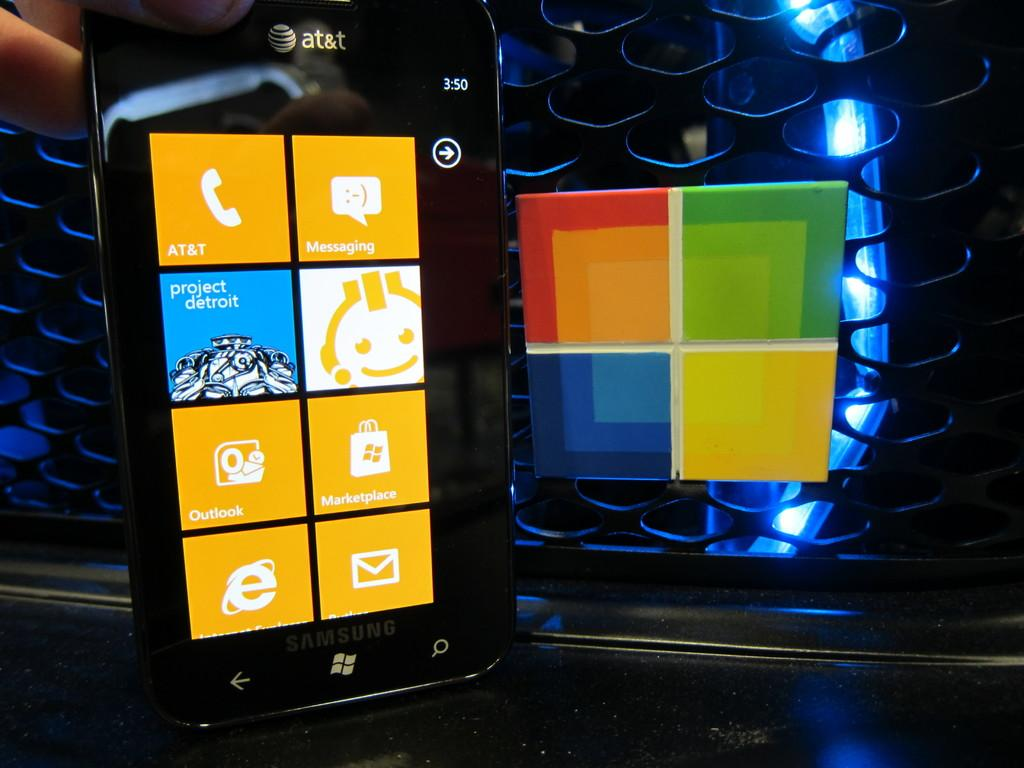What electronic device is present in the image? There is a phone in the image. What other object can be seen in the image besides the phone? There is a colorful board on a mesh in the image. What color is the light visible in the background of the image? There is a blue light visible in the background of the image. What type of stone is being dropped into the phone in the image? There is no stone or action of dropping anything into the phone in the image. 